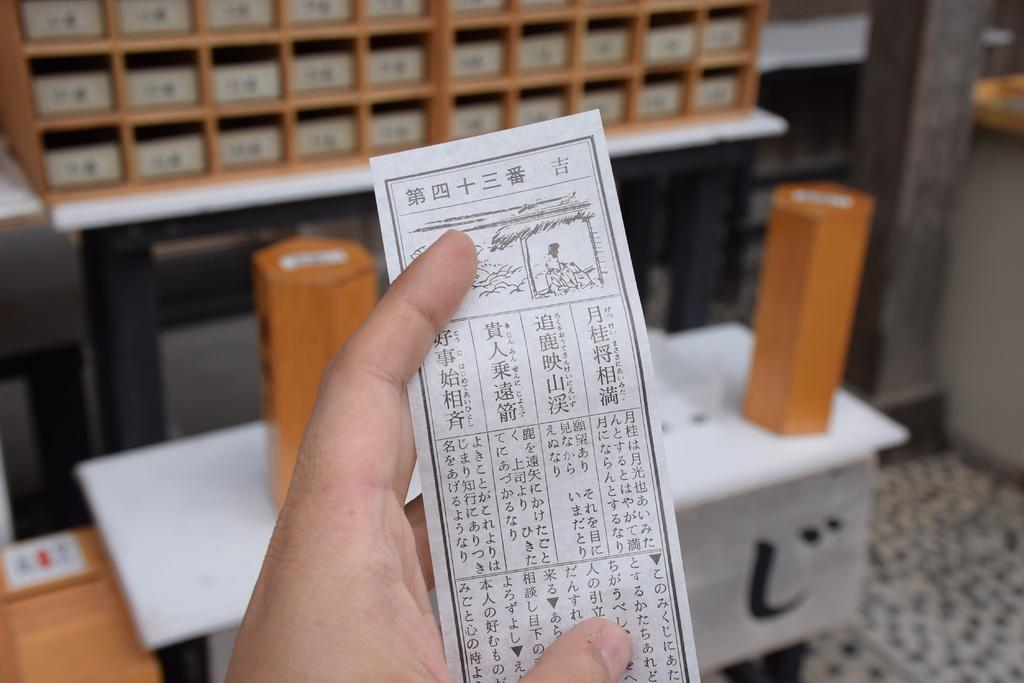What is the person's hand holding in the image? There is a person's hand holding a paper in the image. What can be seen in the background of the image? There are shelves in the background of the image. What is on the shelves? There are objects on the shelves. What type of knee is visible in the image? There is no knee visible in the image; it only shows a person's hand holding a paper and shelves with objects in the background. 